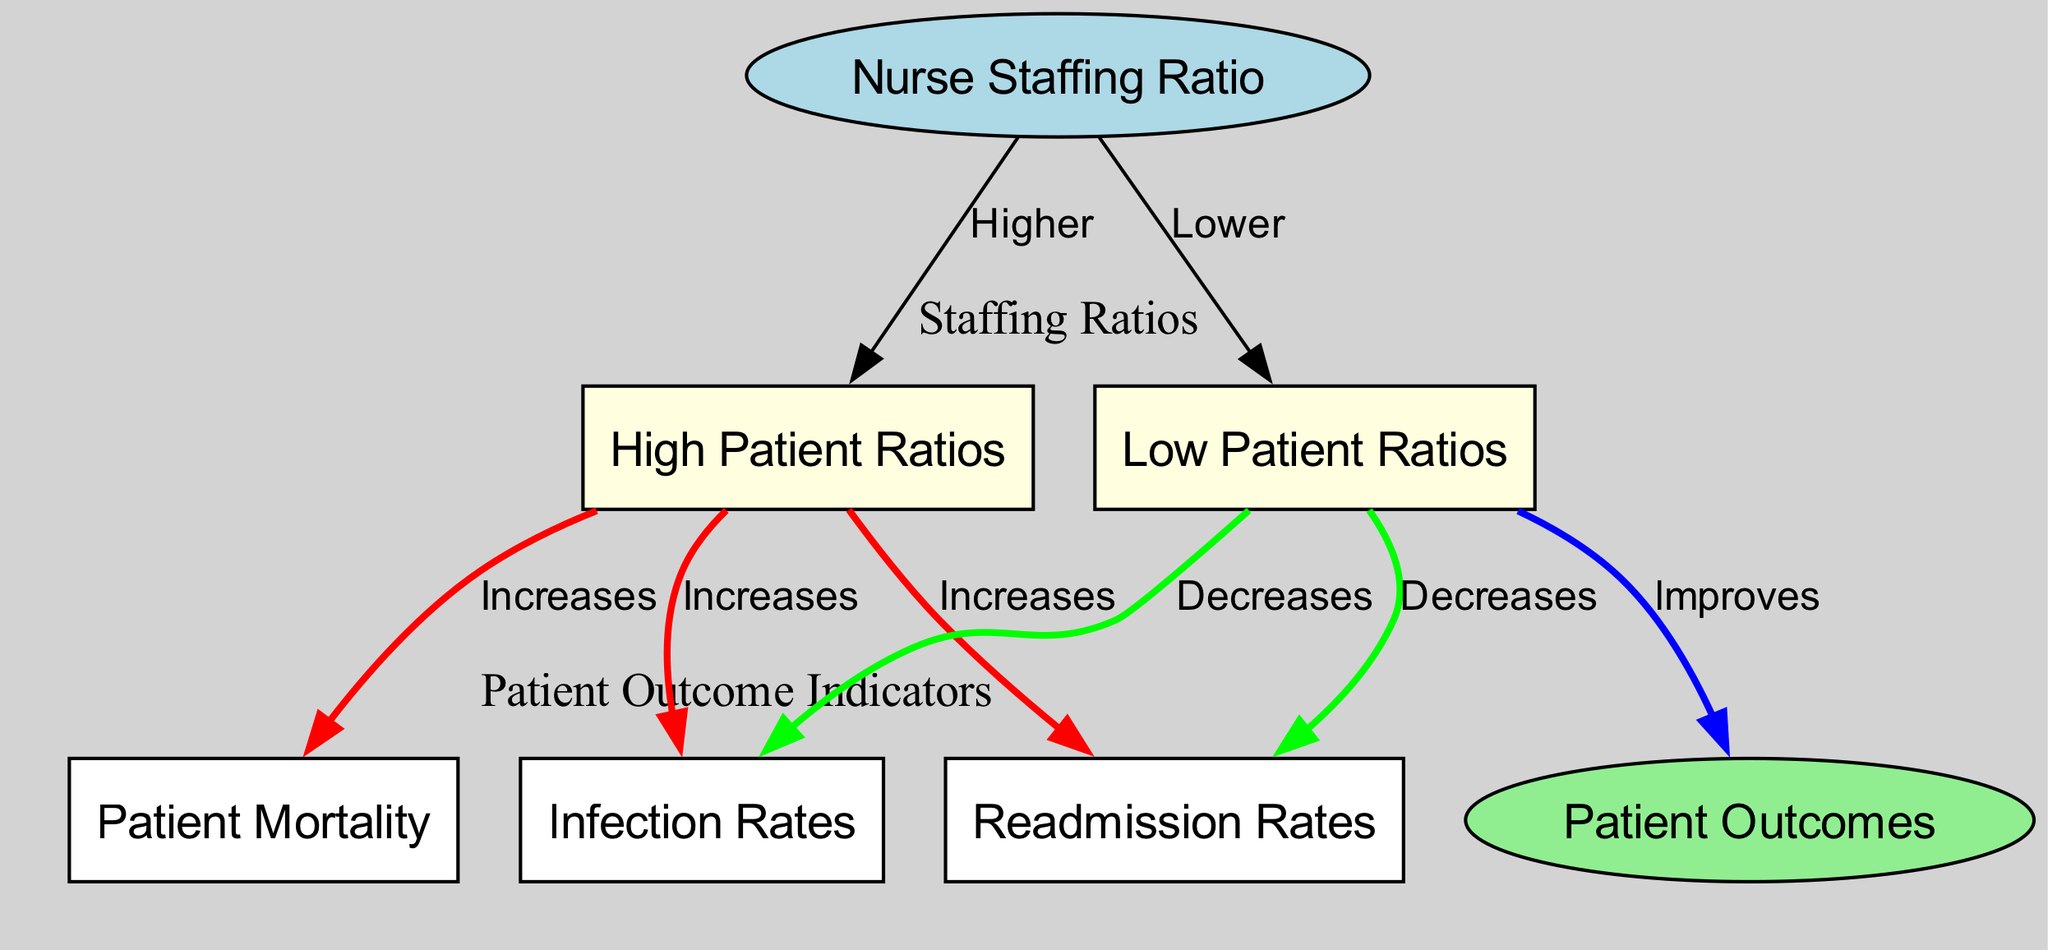What is the main subject of the diagram? The main subject is the relationship between nurse staffing ratios and patient outcomes. This can be identified by looking at the title and the primary nodes in the diagram, specifically the node labeled "Nurse Staffing Ratio" connected to "Patient Outcomes."
Answer: Nurse Staffing Ratios and Patient Outcomes How many nodes are present in the diagram? By counting each unique node listed in the data, we find there are a total of 7 nodes: "Nurse Staffing Ratio", "Patient Outcomes", "High Patient Ratios", "Low Patient Ratios", "Patient Mortality", "Infection Rates", and "Readmission Rates."
Answer: 7 What happens to patient mortality when nurse staffing ratios are high? Looking at the edge between "High Patient Ratios" and "Patient Mortality," it indicates that high patient ratios increase mortality rates. The relationship is explicitly stated with the label "Increases."
Answer: Increases How does a low nurse staffing ratio affect infection rates? The edge from "Low Patient Ratios" to "Infection Rates" shows a decrease in infection rates associated with lower ratios. This can be interpreted directly from the diagram where the relationship is marked as "Decreases."
Answer: Decreases What is the effect of high patient ratios on readmission rates? The diagram connects "High Patient Ratios" to "Readmission Rates," with the edge indicating that high ratios lead to an increase in readmission rates. This relationship is also labeled clearly as "Increases."
Answer: Increases What is the relationship between nurse staffing ratios and patient outcomes when the ratios are low? The edges leading from "Low Patient Ratios" to "Patient Outcomes," as well as the other outcome indicators (infection and readmission rates), suggest that lower staffing ratios improve patient outcomes. This is denoted in the edges labeled "Improves" and "Decreases."
Answer: Improves How does increasing the nurse staffing ratio impact overall patient outcomes? The diagram suggests that higher nurse staffing ratios correlate with negative outcomes as indicated by the connections to "High Patient Ratios" which adversely affects patient mortality, infection rates, and readmission rates.
Answer: Negative impact What color represents low patient ratios in the diagram? The color of the node representing "Low Patient Ratios" is light yellow, which helps in identifying and visually distinguishing it from other nodes in the diagram.
Answer: Light yellow What do the edges labeled "Increases" signify in the context of the diagram? The edges labeled "Increases" indicate a negative impact on patient outcomes when linked to "High Patient Ratios." This relationship is shown with red color edges in the diagram, emphasizing worsening conditions.
Answer: Negative impact 